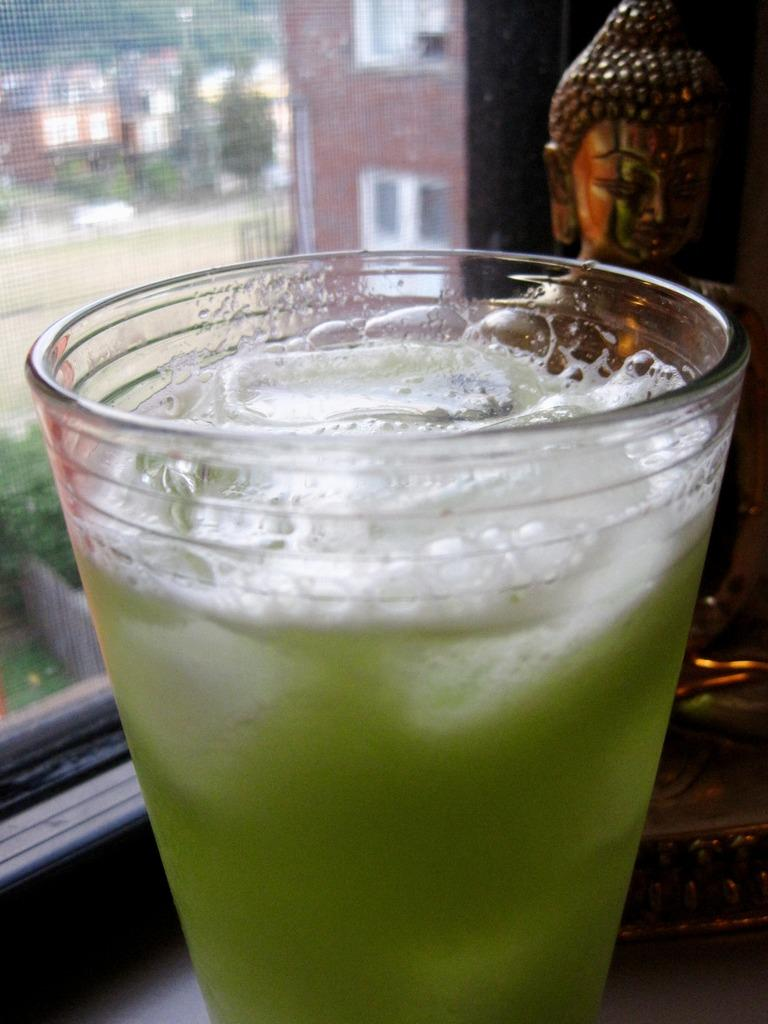What object is present in the image that can hold a liquid? There is a glass in the image that can hold a liquid. What type of liquid is in the glass? The glass contains a liquid in green color. What can be seen in the background of the image? There is a glass window and a building in the background of the image. What is the color of the building in the background? The building is brown in color. How much dust can be seen on the glass in the image? There is no mention of dust in the image, so it cannot be determined how much dust is present. 